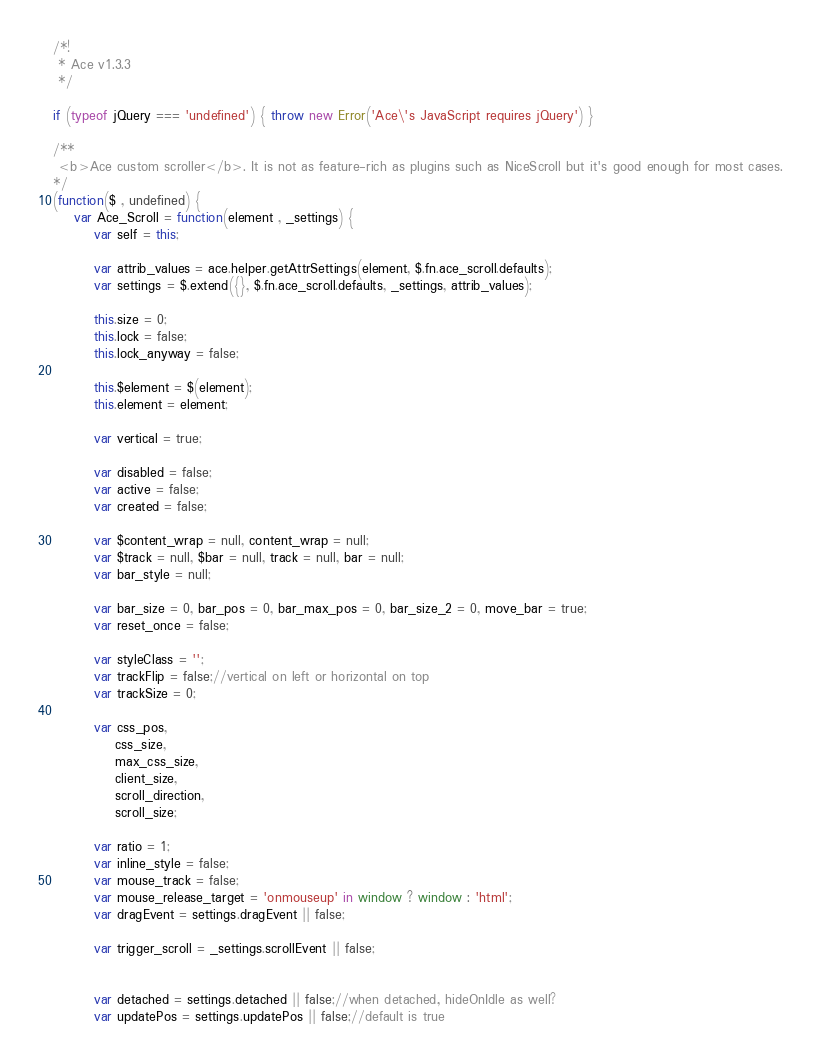Convert code to text. <code><loc_0><loc_0><loc_500><loc_500><_JavaScript_>/*!
 * Ace v1.3.3
 */

if (typeof jQuery === 'undefined') { throw new Error('Ace\'s JavaScript requires jQuery') }

/**
 <b>Ace custom scroller</b>. It is not as feature-rich as plugins such as NiceScroll but it's good enough for most cases.
*/
(function($ , undefined) {
	var Ace_Scroll = function(element , _settings) {
		var self = this;
		
		var attrib_values = ace.helper.getAttrSettings(element, $.fn.ace_scroll.defaults);
		var settings = $.extend({}, $.fn.ace_scroll.defaults, _settings, attrib_values);
	
		this.size = 0;
		this.lock = false;
		this.lock_anyway = false;
		
		this.$element = $(element);
		this.element = element;
		
		var vertical = true;

		var disabled = false;
		var active = false;
		var created = false;

		var $content_wrap = null, content_wrap = null;
		var $track = null, $bar = null, track = null, bar = null;
		var bar_style = null;
		
		var bar_size = 0, bar_pos = 0, bar_max_pos = 0, bar_size_2 = 0, move_bar = true;
		var reset_once = false;
		
		var styleClass = '';
		var trackFlip = false;//vertical on left or horizontal on top
		var trackSize = 0;

		var css_pos,
			css_size,
			max_css_size,
			client_size,
			scroll_direction,
			scroll_size;

		var ratio = 1;
		var inline_style = false;
		var mouse_track = false;
		var mouse_release_target = 'onmouseup' in window ? window : 'html';
		var dragEvent = settings.dragEvent || false;
		
		var trigger_scroll = _settings.scrollEvent || false;
		
		
		var detached = settings.detached || false;//when detached, hideOnIdle as well?
		var updatePos = settings.updatePos || false;//default is true</code> 